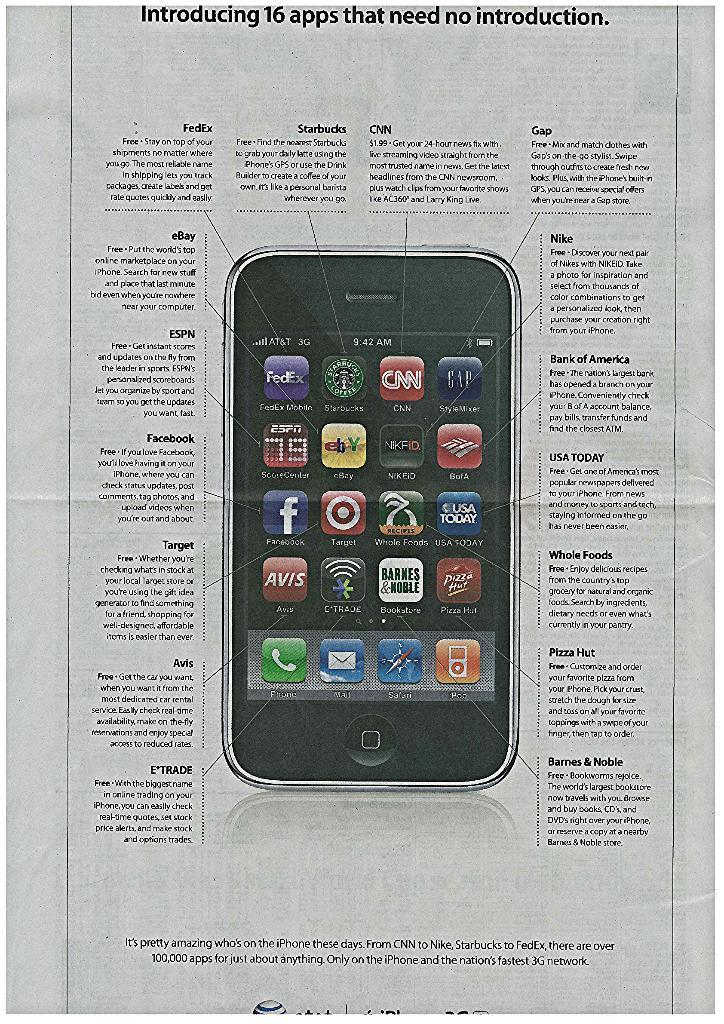<image>
Create a compact narrative representing the image presented. An ad with an iphone on it that has different blurbs of info around it such as Nike, USA Today and Whole Foods. 